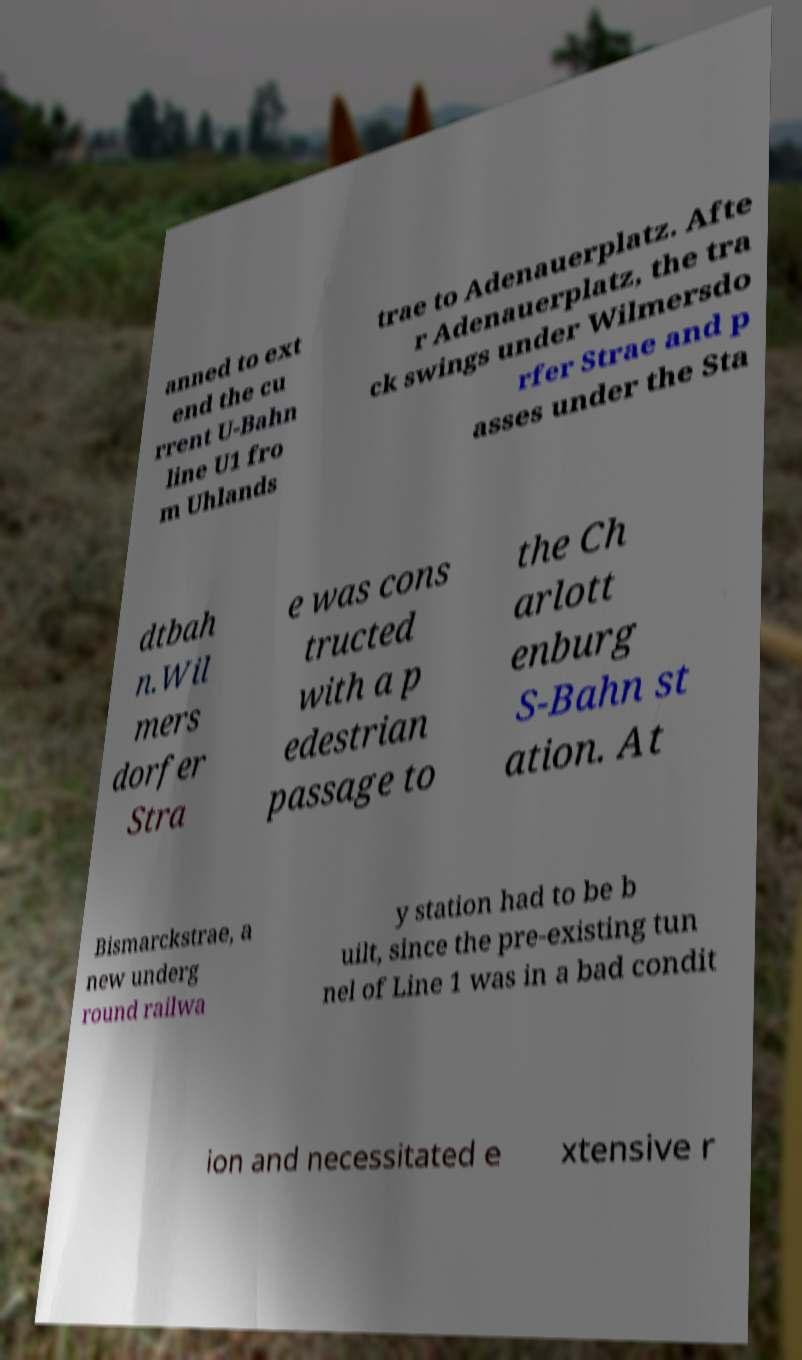Please identify and transcribe the text found in this image. anned to ext end the cu rrent U-Bahn line U1 fro m Uhlands trae to Adenauerplatz. Afte r Adenauerplatz, the tra ck swings under Wilmersdo rfer Strae and p asses under the Sta dtbah n.Wil mers dorfer Stra e was cons tructed with a p edestrian passage to the Ch arlott enburg S-Bahn st ation. At Bismarckstrae, a new underg round railwa y station had to be b uilt, since the pre-existing tun nel of Line 1 was in a bad condit ion and necessitated e xtensive r 